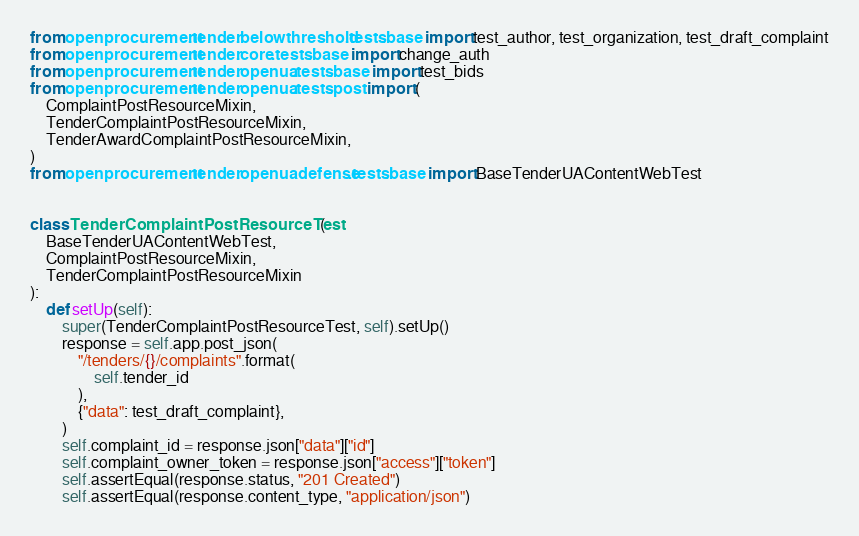<code> <loc_0><loc_0><loc_500><loc_500><_Python_>from openprocurement.tender.belowthreshold.tests.base import test_author, test_organization, test_draft_complaint
from openprocurement.tender.core.tests.base import change_auth
from openprocurement.tender.openua.tests.base import test_bids
from openprocurement.tender.openua.tests.post import (
    ComplaintPostResourceMixin,
    TenderComplaintPostResourceMixin,
    TenderAwardComplaintPostResourceMixin,
)
from openprocurement.tender.openuadefense.tests.base import BaseTenderUAContentWebTest


class TenderComplaintPostResourceTest(
    BaseTenderUAContentWebTest,
    ComplaintPostResourceMixin,
    TenderComplaintPostResourceMixin
):
    def setUp(self):
        super(TenderComplaintPostResourceTest, self).setUp()
        response = self.app.post_json(
            "/tenders/{}/complaints".format(
                self.tender_id
            ),
            {"data": test_draft_complaint},
        )
        self.complaint_id = response.json["data"]["id"]
        self.complaint_owner_token = response.json["access"]["token"]
        self.assertEqual(response.status, "201 Created")
        self.assertEqual(response.content_type, "application/json")

</code> 